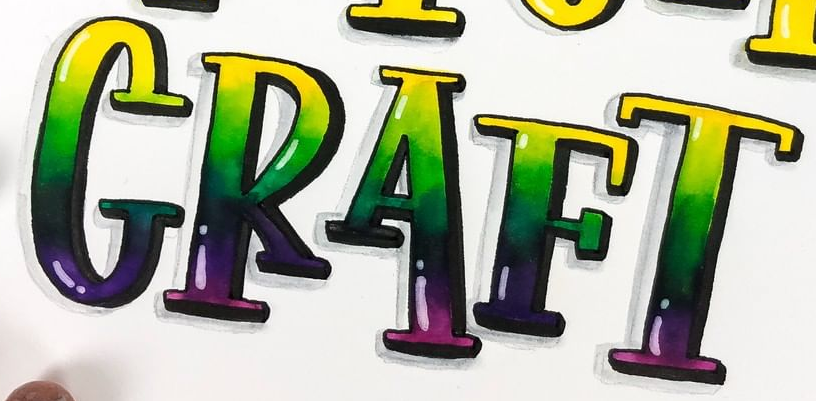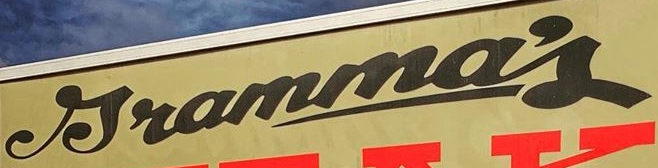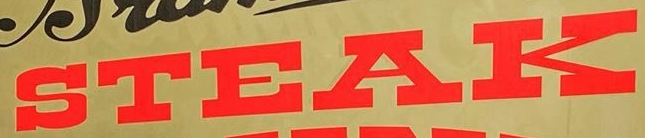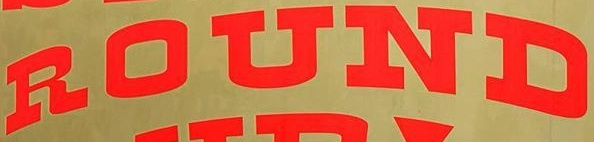Identify the words shown in these images in order, separated by a semicolon. CRAFT; Jramma's; STEAK; ROUND 